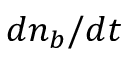Convert formula to latex. <formula><loc_0><loc_0><loc_500><loc_500>d n _ { b } / d t</formula> 